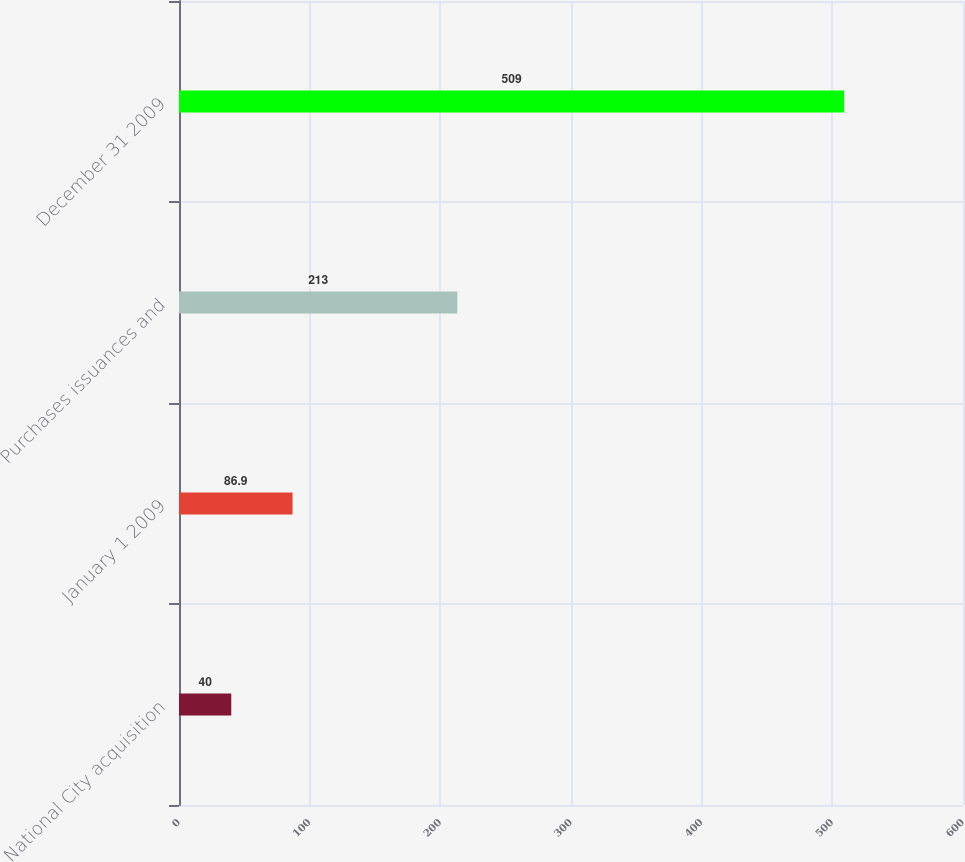Convert chart. <chart><loc_0><loc_0><loc_500><loc_500><bar_chart><fcel>National City acquisition<fcel>January 1 2009<fcel>Purchases issuances and<fcel>December 31 2009<nl><fcel>40<fcel>86.9<fcel>213<fcel>509<nl></chart> 